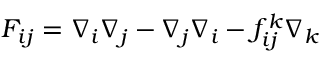Convert formula to latex. <formula><loc_0><loc_0><loc_500><loc_500>F _ { i j } = \nabla _ { i } \nabla _ { j } - \nabla _ { j } \nabla _ { i } - f _ { i j } ^ { k } \nabla _ { k }</formula> 